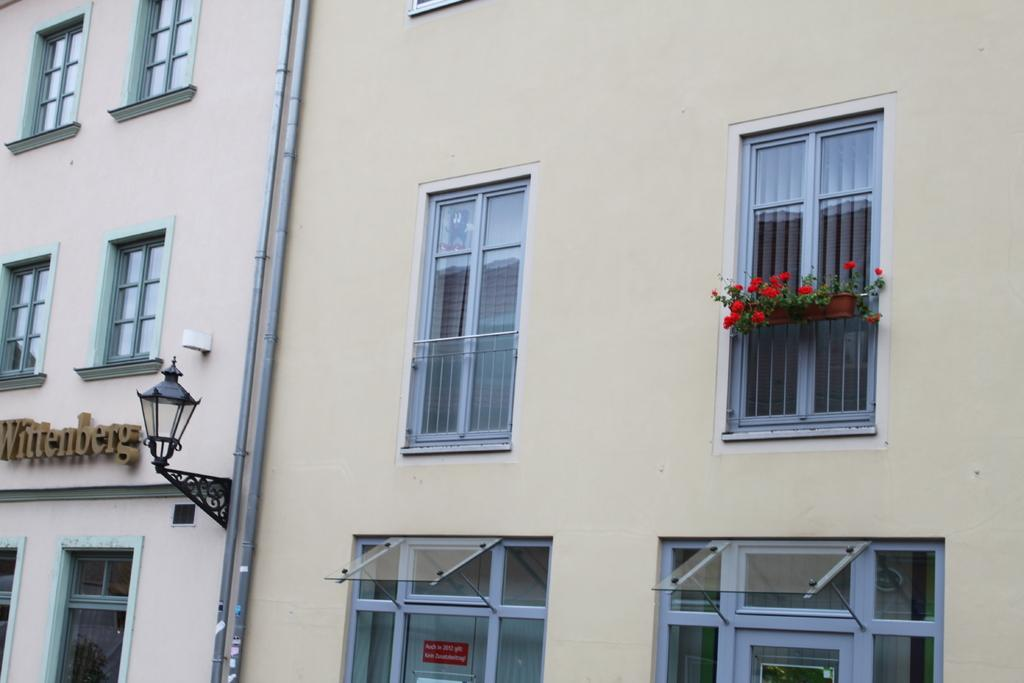What type of structure is shown in the image? The image shows the sidewall of a building. What can be seen on the building's exterior? There are many windows and flower pots on the building. Are there any other features visible on the building? Yes, a pipeline is present on the building. What else can be seen in the image? A lamp post is visible in the image. Can you tell me how many people are drinking from the heart in the image? There is no heart or people drinking in the image; it shows the sidewall of a building with windows, flower pots, a pipeline, and a lamp post. 